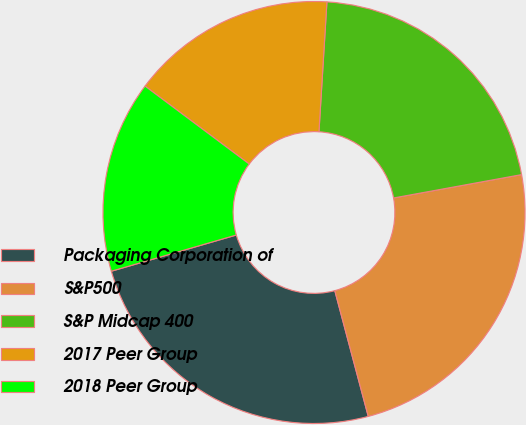<chart> <loc_0><loc_0><loc_500><loc_500><pie_chart><fcel>Packaging Corporation of<fcel>S&P500<fcel>S&P Midcap 400<fcel>2017 Peer Group<fcel>2018 Peer Group<nl><fcel>24.65%<fcel>23.73%<fcel>21.15%<fcel>15.75%<fcel>14.71%<nl></chart> 